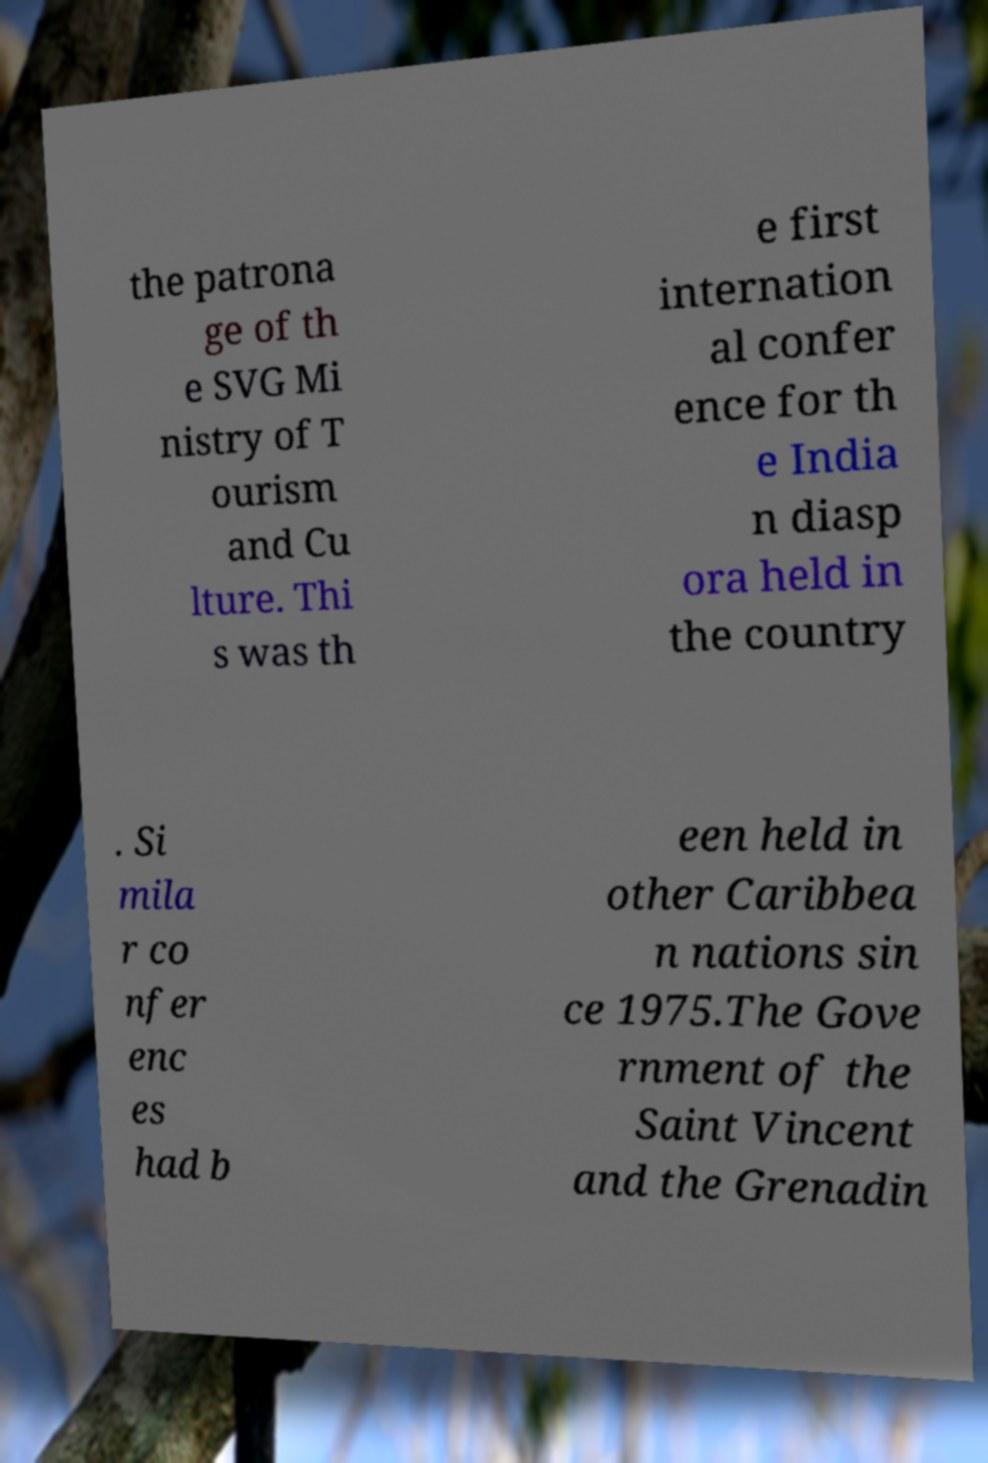Could you assist in decoding the text presented in this image and type it out clearly? the patrona ge of th e SVG Mi nistry of T ourism and Cu lture. Thi s was th e first internation al confer ence for th e India n diasp ora held in the country . Si mila r co nfer enc es had b een held in other Caribbea n nations sin ce 1975.The Gove rnment of the Saint Vincent and the Grenadin 